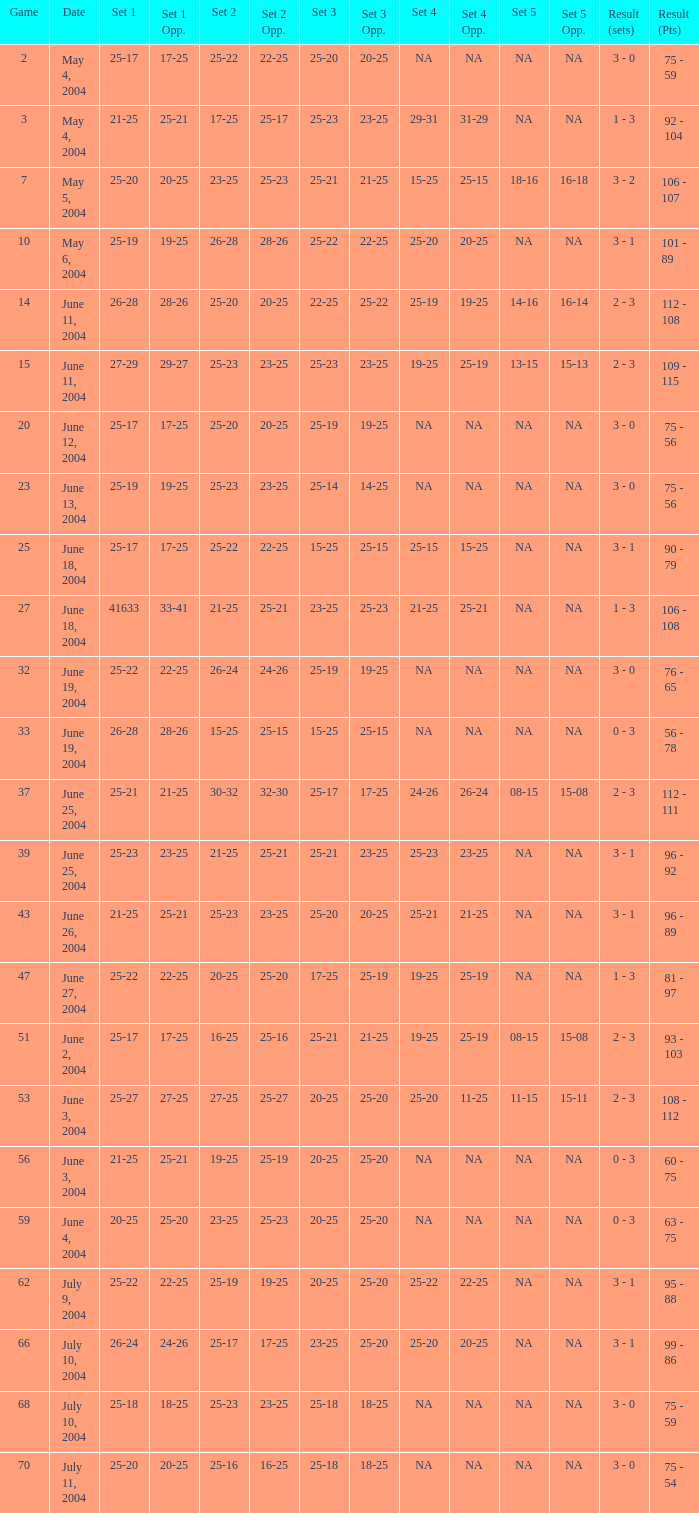What is the set 5 for the game with a set 2 of 21-25 and a set 1 of 41633? NA. 